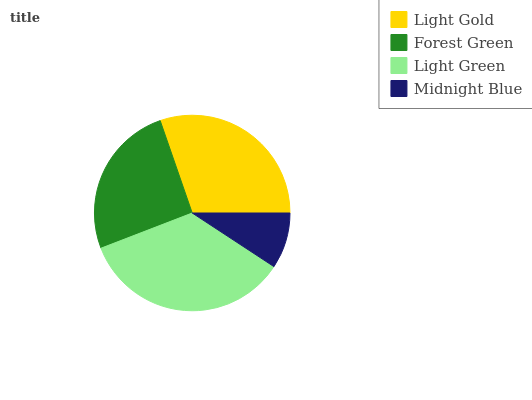Is Midnight Blue the minimum?
Answer yes or no. Yes. Is Light Green the maximum?
Answer yes or no. Yes. Is Forest Green the minimum?
Answer yes or no. No. Is Forest Green the maximum?
Answer yes or no. No. Is Light Gold greater than Forest Green?
Answer yes or no. Yes. Is Forest Green less than Light Gold?
Answer yes or no. Yes. Is Forest Green greater than Light Gold?
Answer yes or no. No. Is Light Gold less than Forest Green?
Answer yes or no. No. Is Light Gold the high median?
Answer yes or no. Yes. Is Forest Green the low median?
Answer yes or no. Yes. Is Light Green the high median?
Answer yes or no. No. Is Light Green the low median?
Answer yes or no. No. 